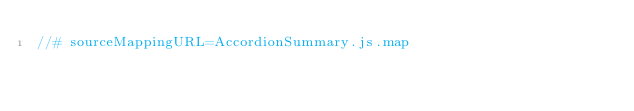Convert code to text. <code><loc_0><loc_0><loc_500><loc_500><_JavaScript_>//# sourceMappingURL=AccordionSummary.js.map</code> 